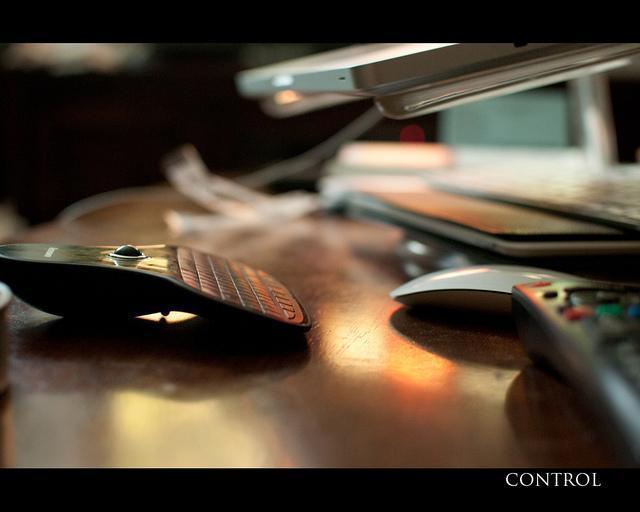How many keyboards are in the picture?
Give a very brief answer. 3. How many remotes can be seen?
Give a very brief answer. 2. How many people will this pizza feed?
Give a very brief answer. 0. 